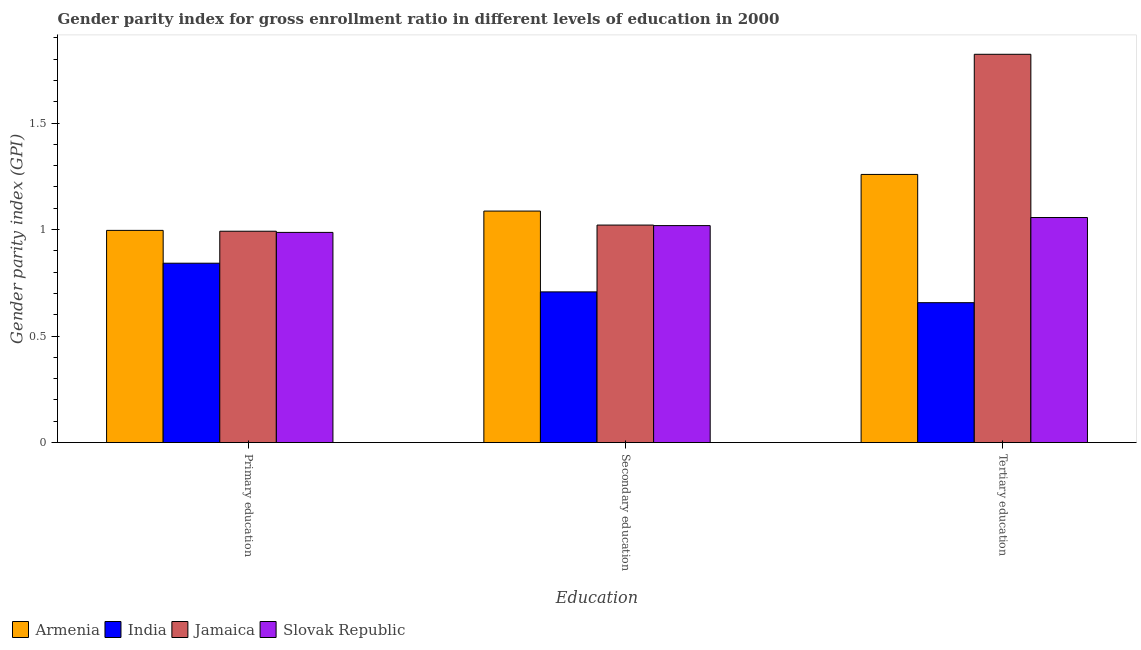What is the gender parity index in primary education in India?
Your answer should be compact. 0.84. Across all countries, what is the maximum gender parity index in tertiary education?
Give a very brief answer. 1.82. Across all countries, what is the minimum gender parity index in tertiary education?
Your response must be concise. 0.66. In which country was the gender parity index in primary education maximum?
Offer a terse response. Armenia. In which country was the gender parity index in tertiary education minimum?
Provide a succinct answer. India. What is the total gender parity index in secondary education in the graph?
Offer a very short reply. 3.83. What is the difference between the gender parity index in tertiary education in Armenia and that in Slovak Republic?
Offer a terse response. 0.2. What is the difference between the gender parity index in tertiary education in India and the gender parity index in secondary education in Jamaica?
Offer a terse response. -0.36. What is the average gender parity index in secondary education per country?
Provide a succinct answer. 0.96. What is the difference between the gender parity index in secondary education and gender parity index in tertiary education in Jamaica?
Provide a short and direct response. -0.8. In how many countries, is the gender parity index in primary education greater than 1.8 ?
Ensure brevity in your answer.  0. What is the ratio of the gender parity index in secondary education in Jamaica to that in India?
Provide a short and direct response. 1.44. Is the gender parity index in secondary education in Jamaica less than that in India?
Provide a short and direct response. No. Is the difference between the gender parity index in tertiary education in Armenia and India greater than the difference between the gender parity index in primary education in Armenia and India?
Your answer should be compact. Yes. What is the difference between the highest and the second highest gender parity index in primary education?
Keep it short and to the point. 0. What is the difference between the highest and the lowest gender parity index in primary education?
Provide a succinct answer. 0.15. In how many countries, is the gender parity index in secondary education greater than the average gender parity index in secondary education taken over all countries?
Give a very brief answer. 3. What does the 1st bar from the left in Secondary education represents?
Offer a terse response. Armenia. What does the 1st bar from the right in Secondary education represents?
Offer a terse response. Slovak Republic. Are all the bars in the graph horizontal?
Offer a very short reply. No. What is the difference between two consecutive major ticks on the Y-axis?
Offer a terse response. 0.5. How are the legend labels stacked?
Make the answer very short. Horizontal. What is the title of the graph?
Ensure brevity in your answer.  Gender parity index for gross enrollment ratio in different levels of education in 2000. What is the label or title of the X-axis?
Keep it short and to the point. Education. What is the label or title of the Y-axis?
Your response must be concise. Gender parity index (GPI). What is the Gender parity index (GPI) in Armenia in Primary education?
Ensure brevity in your answer.  1. What is the Gender parity index (GPI) in India in Primary education?
Your answer should be very brief. 0.84. What is the Gender parity index (GPI) of Jamaica in Primary education?
Ensure brevity in your answer.  0.99. What is the Gender parity index (GPI) in Slovak Republic in Primary education?
Offer a terse response. 0.99. What is the Gender parity index (GPI) of Armenia in Secondary education?
Make the answer very short. 1.09. What is the Gender parity index (GPI) in India in Secondary education?
Provide a succinct answer. 0.71. What is the Gender parity index (GPI) of Jamaica in Secondary education?
Give a very brief answer. 1.02. What is the Gender parity index (GPI) of Slovak Republic in Secondary education?
Provide a succinct answer. 1.02. What is the Gender parity index (GPI) of Armenia in Tertiary education?
Offer a terse response. 1.26. What is the Gender parity index (GPI) of India in Tertiary education?
Keep it short and to the point. 0.66. What is the Gender parity index (GPI) of Jamaica in Tertiary education?
Offer a terse response. 1.82. What is the Gender parity index (GPI) in Slovak Republic in Tertiary education?
Give a very brief answer. 1.06. Across all Education, what is the maximum Gender parity index (GPI) of Armenia?
Provide a succinct answer. 1.26. Across all Education, what is the maximum Gender parity index (GPI) in India?
Ensure brevity in your answer.  0.84. Across all Education, what is the maximum Gender parity index (GPI) in Jamaica?
Offer a very short reply. 1.82. Across all Education, what is the maximum Gender parity index (GPI) of Slovak Republic?
Give a very brief answer. 1.06. Across all Education, what is the minimum Gender parity index (GPI) in Armenia?
Keep it short and to the point. 1. Across all Education, what is the minimum Gender parity index (GPI) in India?
Keep it short and to the point. 0.66. Across all Education, what is the minimum Gender parity index (GPI) of Jamaica?
Provide a short and direct response. 0.99. Across all Education, what is the minimum Gender parity index (GPI) in Slovak Republic?
Offer a very short reply. 0.99. What is the total Gender parity index (GPI) in Armenia in the graph?
Provide a succinct answer. 3.34. What is the total Gender parity index (GPI) in India in the graph?
Offer a terse response. 2.21. What is the total Gender parity index (GPI) in Jamaica in the graph?
Offer a very short reply. 3.84. What is the total Gender parity index (GPI) of Slovak Republic in the graph?
Offer a terse response. 3.06. What is the difference between the Gender parity index (GPI) in Armenia in Primary education and that in Secondary education?
Your answer should be very brief. -0.09. What is the difference between the Gender parity index (GPI) in India in Primary education and that in Secondary education?
Offer a very short reply. 0.13. What is the difference between the Gender parity index (GPI) in Jamaica in Primary education and that in Secondary education?
Offer a very short reply. -0.03. What is the difference between the Gender parity index (GPI) in Slovak Republic in Primary education and that in Secondary education?
Your answer should be compact. -0.03. What is the difference between the Gender parity index (GPI) of Armenia in Primary education and that in Tertiary education?
Offer a terse response. -0.26. What is the difference between the Gender parity index (GPI) of India in Primary education and that in Tertiary education?
Your answer should be very brief. 0.19. What is the difference between the Gender parity index (GPI) of Jamaica in Primary education and that in Tertiary education?
Provide a succinct answer. -0.83. What is the difference between the Gender parity index (GPI) in Slovak Republic in Primary education and that in Tertiary education?
Provide a succinct answer. -0.07. What is the difference between the Gender parity index (GPI) in Armenia in Secondary education and that in Tertiary education?
Your answer should be very brief. -0.17. What is the difference between the Gender parity index (GPI) in India in Secondary education and that in Tertiary education?
Provide a succinct answer. 0.05. What is the difference between the Gender parity index (GPI) of Jamaica in Secondary education and that in Tertiary education?
Make the answer very short. -0.8. What is the difference between the Gender parity index (GPI) of Slovak Republic in Secondary education and that in Tertiary education?
Make the answer very short. -0.04. What is the difference between the Gender parity index (GPI) of Armenia in Primary education and the Gender parity index (GPI) of India in Secondary education?
Keep it short and to the point. 0.29. What is the difference between the Gender parity index (GPI) in Armenia in Primary education and the Gender parity index (GPI) in Jamaica in Secondary education?
Your answer should be very brief. -0.02. What is the difference between the Gender parity index (GPI) of Armenia in Primary education and the Gender parity index (GPI) of Slovak Republic in Secondary education?
Give a very brief answer. -0.02. What is the difference between the Gender parity index (GPI) in India in Primary education and the Gender parity index (GPI) in Jamaica in Secondary education?
Make the answer very short. -0.18. What is the difference between the Gender parity index (GPI) of India in Primary education and the Gender parity index (GPI) of Slovak Republic in Secondary education?
Offer a very short reply. -0.18. What is the difference between the Gender parity index (GPI) of Jamaica in Primary education and the Gender parity index (GPI) of Slovak Republic in Secondary education?
Offer a very short reply. -0.03. What is the difference between the Gender parity index (GPI) in Armenia in Primary education and the Gender parity index (GPI) in India in Tertiary education?
Your response must be concise. 0.34. What is the difference between the Gender parity index (GPI) of Armenia in Primary education and the Gender parity index (GPI) of Jamaica in Tertiary education?
Keep it short and to the point. -0.83. What is the difference between the Gender parity index (GPI) in Armenia in Primary education and the Gender parity index (GPI) in Slovak Republic in Tertiary education?
Provide a short and direct response. -0.06. What is the difference between the Gender parity index (GPI) of India in Primary education and the Gender parity index (GPI) of Jamaica in Tertiary education?
Make the answer very short. -0.98. What is the difference between the Gender parity index (GPI) of India in Primary education and the Gender parity index (GPI) of Slovak Republic in Tertiary education?
Your answer should be very brief. -0.21. What is the difference between the Gender parity index (GPI) of Jamaica in Primary education and the Gender parity index (GPI) of Slovak Republic in Tertiary education?
Keep it short and to the point. -0.06. What is the difference between the Gender parity index (GPI) in Armenia in Secondary education and the Gender parity index (GPI) in India in Tertiary education?
Make the answer very short. 0.43. What is the difference between the Gender parity index (GPI) in Armenia in Secondary education and the Gender parity index (GPI) in Jamaica in Tertiary education?
Give a very brief answer. -0.74. What is the difference between the Gender parity index (GPI) of Armenia in Secondary education and the Gender parity index (GPI) of Slovak Republic in Tertiary education?
Offer a terse response. 0.03. What is the difference between the Gender parity index (GPI) of India in Secondary education and the Gender parity index (GPI) of Jamaica in Tertiary education?
Your answer should be compact. -1.12. What is the difference between the Gender parity index (GPI) in India in Secondary education and the Gender parity index (GPI) in Slovak Republic in Tertiary education?
Ensure brevity in your answer.  -0.35. What is the difference between the Gender parity index (GPI) in Jamaica in Secondary education and the Gender parity index (GPI) in Slovak Republic in Tertiary education?
Your response must be concise. -0.04. What is the average Gender parity index (GPI) in Armenia per Education?
Provide a short and direct response. 1.11. What is the average Gender parity index (GPI) of India per Education?
Offer a terse response. 0.74. What is the average Gender parity index (GPI) of Jamaica per Education?
Your response must be concise. 1.28. What is the average Gender parity index (GPI) in Slovak Republic per Education?
Provide a short and direct response. 1.02. What is the difference between the Gender parity index (GPI) in Armenia and Gender parity index (GPI) in India in Primary education?
Your answer should be very brief. 0.15. What is the difference between the Gender parity index (GPI) in Armenia and Gender parity index (GPI) in Jamaica in Primary education?
Ensure brevity in your answer.  0. What is the difference between the Gender parity index (GPI) of Armenia and Gender parity index (GPI) of Slovak Republic in Primary education?
Provide a succinct answer. 0.01. What is the difference between the Gender parity index (GPI) in India and Gender parity index (GPI) in Jamaica in Primary education?
Your answer should be very brief. -0.15. What is the difference between the Gender parity index (GPI) in India and Gender parity index (GPI) in Slovak Republic in Primary education?
Provide a short and direct response. -0.14. What is the difference between the Gender parity index (GPI) in Jamaica and Gender parity index (GPI) in Slovak Republic in Primary education?
Your answer should be very brief. 0.01. What is the difference between the Gender parity index (GPI) of Armenia and Gender parity index (GPI) of India in Secondary education?
Your answer should be compact. 0.38. What is the difference between the Gender parity index (GPI) in Armenia and Gender parity index (GPI) in Jamaica in Secondary education?
Offer a terse response. 0.07. What is the difference between the Gender parity index (GPI) of Armenia and Gender parity index (GPI) of Slovak Republic in Secondary education?
Your answer should be very brief. 0.07. What is the difference between the Gender parity index (GPI) of India and Gender parity index (GPI) of Jamaica in Secondary education?
Offer a very short reply. -0.31. What is the difference between the Gender parity index (GPI) of India and Gender parity index (GPI) of Slovak Republic in Secondary education?
Give a very brief answer. -0.31. What is the difference between the Gender parity index (GPI) of Jamaica and Gender parity index (GPI) of Slovak Republic in Secondary education?
Provide a short and direct response. 0. What is the difference between the Gender parity index (GPI) in Armenia and Gender parity index (GPI) in India in Tertiary education?
Provide a short and direct response. 0.6. What is the difference between the Gender parity index (GPI) of Armenia and Gender parity index (GPI) of Jamaica in Tertiary education?
Provide a short and direct response. -0.56. What is the difference between the Gender parity index (GPI) in Armenia and Gender parity index (GPI) in Slovak Republic in Tertiary education?
Ensure brevity in your answer.  0.2. What is the difference between the Gender parity index (GPI) of India and Gender parity index (GPI) of Jamaica in Tertiary education?
Give a very brief answer. -1.17. What is the difference between the Gender parity index (GPI) of India and Gender parity index (GPI) of Slovak Republic in Tertiary education?
Offer a terse response. -0.4. What is the difference between the Gender parity index (GPI) in Jamaica and Gender parity index (GPI) in Slovak Republic in Tertiary education?
Offer a terse response. 0.77. What is the ratio of the Gender parity index (GPI) in Armenia in Primary education to that in Secondary education?
Your answer should be very brief. 0.92. What is the ratio of the Gender parity index (GPI) of India in Primary education to that in Secondary education?
Provide a short and direct response. 1.19. What is the ratio of the Gender parity index (GPI) of Jamaica in Primary education to that in Secondary education?
Give a very brief answer. 0.97. What is the ratio of the Gender parity index (GPI) in Slovak Republic in Primary education to that in Secondary education?
Give a very brief answer. 0.97. What is the ratio of the Gender parity index (GPI) of Armenia in Primary education to that in Tertiary education?
Ensure brevity in your answer.  0.79. What is the ratio of the Gender parity index (GPI) in India in Primary education to that in Tertiary education?
Keep it short and to the point. 1.28. What is the ratio of the Gender parity index (GPI) in Jamaica in Primary education to that in Tertiary education?
Keep it short and to the point. 0.54. What is the ratio of the Gender parity index (GPI) of Slovak Republic in Primary education to that in Tertiary education?
Give a very brief answer. 0.93. What is the ratio of the Gender parity index (GPI) of Armenia in Secondary education to that in Tertiary education?
Your answer should be compact. 0.86. What is the ratio of the Gender parity index (GPI) of India in Secondary education to that in Tertiary education?
Your answer should be compact. 1.08. What is the ratio of the Gender parity index (GPI) of Jamaica in Secondary education to that in Tertiary education?
Your answer should be very brief. 0.56. What is the ratio of the Gender parity index (GPI) of Slovak Republic in Secondary education to that in Tertiary education?
Offer a terse response. 0.96. What is the difference between the highest and the second highest Gender parity index (GPI) in Armenia?
Provide a short and direct response. 0.17. What is the difference between the highest and the second highest Gender parity index (GPI) in India?
Ensure brevity in your answer.  0.13. What is the difference between the highest and the second highest Gender parity index (GPI) in Jamaica?
Offer a very short reply. 0.8. What is the difference between the highest and the second highest Gender parity index (GPI) of Slovak Republic?
Offer a very short reply. 0.04. What is the difference between the highest and the lowest Gender parity index (GPI) in Armenia?
Offer a terse response. 0.26. What is the difference between the highest and the lowest Gender parity index (GPI) in India?
Your response must be concise. 0.19. What is the difference between the highest and the lowest Gender parity index (GPI) in Jamaica?
Give a very brief answer. 0.83. What is the difference between the highest and the lowest Gender parity index (GPI) in Slovak Republic?
Your response must be concise. 0.07. 